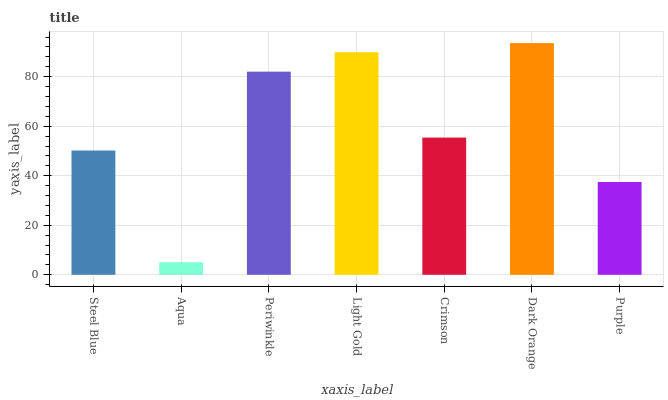Is Periwinkle the minimum?
Answer yes or no. No. Is Periwinkle the maximum?
Answer yes or no. No. Is Periwinkle greater than Aqua?
Answer yes or no. Yes. Is Aqua less than Periwinkle?
Answer yes or no. Yes. Is Aqua greater than Periwinkle?
Answer yes or no. No. Is Periwinkle less than Aqua?
Answer yes or no. No. Is Crimson the high median?
Answer yes or no. Yes. Is Crimson the low median?
Answer yes or no. Yes. Is Light Gold the high median?
Answer yes or no. No. Is Light Gold the low median?
Answer yes or no. No. 